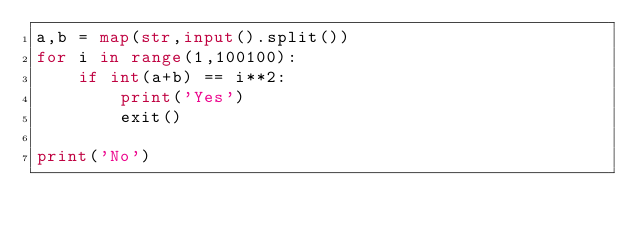<code> <loc_0><loc_0><loc_500><loc_500><_Python_>a,b = map(str,input().split())
for i in range(1,100100):
    if int(a+b) == i**2:
        print('Yes')
        exit()

print('No')</code> 